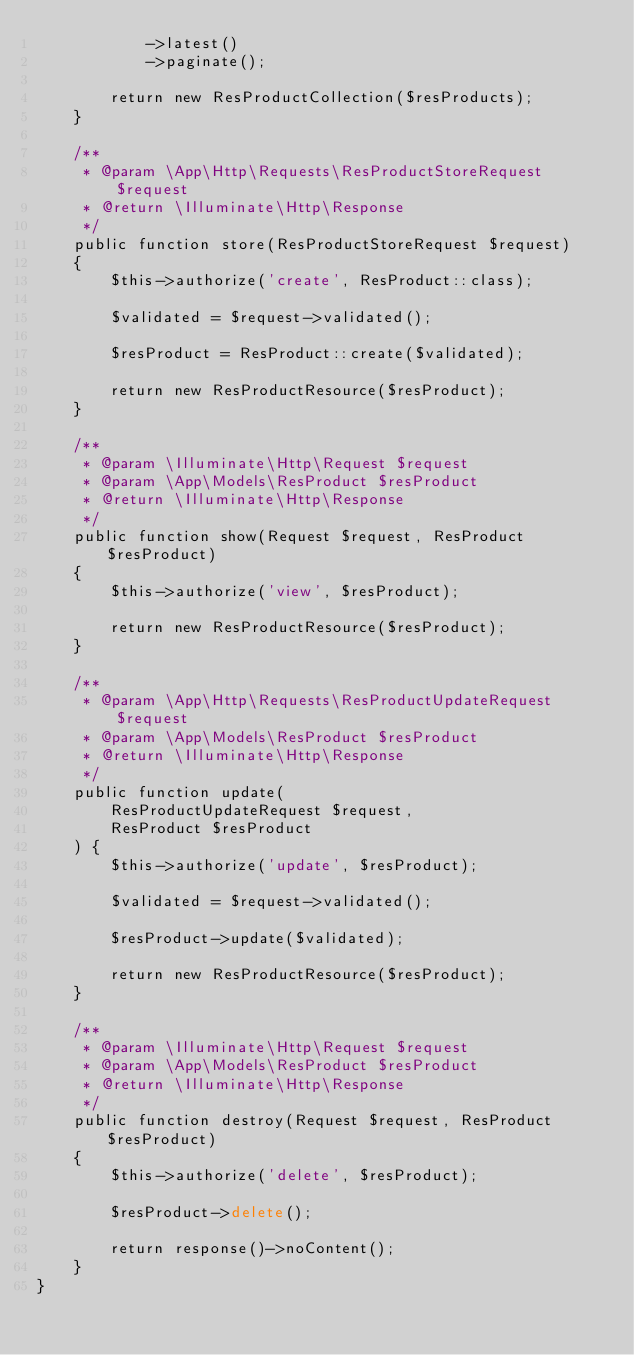Convert code to text. <code><loc_0><loc_0><loc_500><loc_500><_PHP_>            ->latest()
            ->paginate();

        return new ResProductCollection($resProducts);
    }

    /**
     * @param \App\Http\Requests\ResProductStoreRequest $request
     * @return \Illuminate\Http\Response
     */
    public function store(ResProductStoreRequest $request)
    {
        $this->authorize('create', ResProduct::class);

        $validated = $request->validated();

        $resProduct = ResProduct::create($validated);

        return new ResProductResource($resProduct);
    }

    /**
     * @param \Illuminate\Http\Request $request
     * @param \App\Models\ResProduct $resProduct
     * @return \Illuminate\Http\Response
     */
    public function show(Request $request, ResProduct $resProduct)
    {
        $this->authorize('view', $resProduct);

        return new ResProductResource($resProduct);
    }

    /**
     * @param \App\Http\Requests\ResProductUpdateRequest $request
     * @param \App\Models\ResProduct $resProduct
     * @return \Illuminate\Http\Response
     */
    public function update(
        ResProductUpdateRequest $request,
        ResProduct $resProduct
    ) {
        $this->authorize('update', $resProduct);

        $validated = $request->validated();

        $resProduct->update($validated);

        return new ResProductResource($resProduct);
    }

    /**
     * @param \Illuminate\Http\Request $request
     * @param \App\Models\ResProduct $resProduct
     * @return \Illuminate\Http\Response
     */
    public function destroy(Request $request, ResProduct $resProduct)
    {
        $this->authorize('delete', $resProduct);

        $resProduct->delete();

        return response()->noContent();
    }
}
</code> 